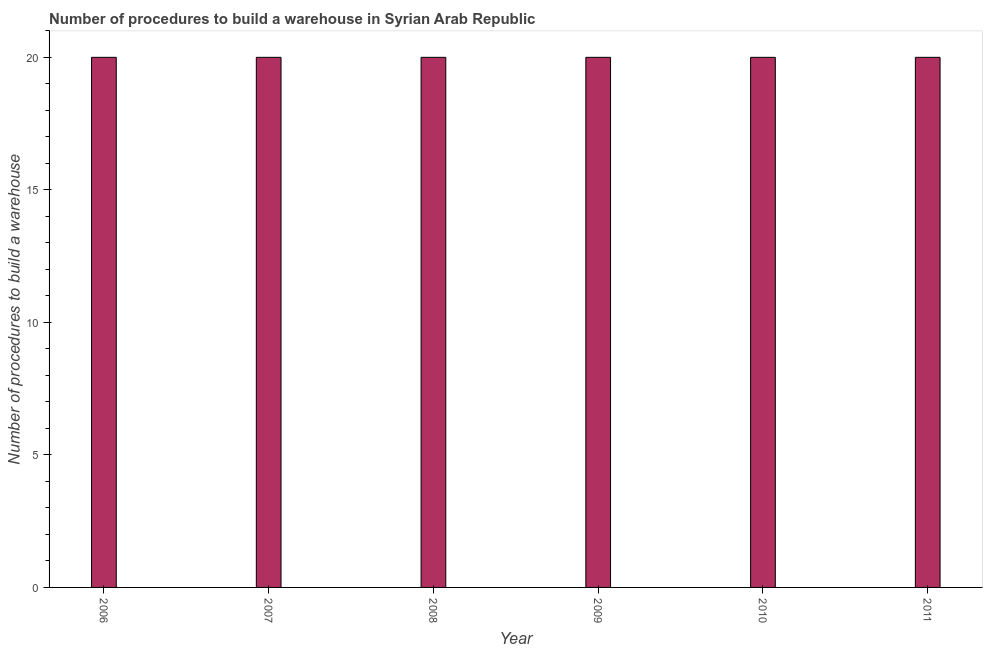Does the graph contain any zero values?
Your answer should be compact. No. What is the title of the graph?
Ensure brevity in your answer.  Number of procedures to build a warehouse in Syrian Arab Republic. What is the label or title of the Y-axis?
Provide a short and direct response. Number of procedures to build a warehouse. Across all years, what is the maximum number of procedures to build a warehouse?
Keep it short and to the point. 20. What is the sum of the number of procedures to build a warehouse?
Provide a short and direct response. 120. What is the difference between the number of procedures to build a warehouse in 2006 and 2009?
Give a very brief answer. 0. What is the median number of procedures to build a warehouse?
Your answer should be compact. 20. What is the ratio of the number of procedures to build a warehouse in 2007 to that in 2011?
Ensure brevity in your answer.  1. Is the number of procedures to build a warehouse in 2006 less than that in 2007?
Make the answer very short. No. Is the difference between the number of procedures to build a warehouse in 2008 and 2009 greater than the difference between any two years?
Provide a succinct answer. Yes. Is the sum of the number of procedures to build a warehouse in 2006 and 2011 greater than the maximum number of procedures to build a warehouse across all years?
Your answer should be compact. Yes. What is the difference between the highest and the lowest number of procedures to build a warehouse?
Provide a short and direct response. 0. How many bars are there?
Your response must be concise. 6. Are all the bars in the graph horizontal?
Provide a succinct answer. No. What is the difference between two consecutive major ticks on the Y-axis?
Your answer should be very brief. 5. Are the values on the major ticks of Y-axis written in scientific E-notation?
Give a very brief answer. No. What is the Number of procedures to build a warehouse in 2006?
Give a very brief answer. 20. What is the Number of procedures to build a warehouse of 2008?
Offer a very short reply. 20. What is the difference between the Number of procedures to build a warehouse in 2006 and 2007?
Ensure brevity in your answer.  0. What is the difference between the Number of procedures to build a warehouse in 2006 and 2011?
Provide a short and direct response. 0. What is the difference between the Number of procedures to build a warehouse in 2007 and 2008?
Your answer should be very brief. 0. What is the difference between the Number of procedures to build a warehouse in 2007 and 2009?
Make the answer very short. 0. What is the difference between the Number of procedures to build a warehouse in 2007 and 2010?
Your answer should be very brief. 0. What is the difference between the Number of procedures to build a warehouse in 2007 and 2011?
Offer a very short reply. 0. What is the difference between the Number of procedures to build a warehouse in 2008 and 2010?
Ensure brevity in your answer.  0. What is the difference between the Number of procedures to build a warehouse in 2009 and 2011?
Provide a succinct answer. 0. What is the difference between the Number of procedures to build a warehouse in 2010 and 2011?
Your answer should be very brief. 0. What is the ratio of the Number of procedures to build a warehouse in 2006 to that in 2007?
Your answer should be very brief. 1. What is the ratio of the Number of procedures to build a warehouse in 2006 to that in 2008?
Offer a terse response. 1. What is the ratio of the Number of procedures to build a warehouse in 2006 to that in 2009?
Give a very brief answer. 1. What is the ratio of the Number of procedures to build a warehouse in 2006 to that in 2011?
Provide a short and direct response. 1. What is the ratio of the Number of procedures to build a warehouse in 2007 to that in 2008?
Give a very brief answer. 1. What is the ratio of the Number of procedures to build a warehouse in 2007 to that in 2009?
Make the answer very short. 1. What is the ratio of the Number of procedures to build a warehouse in 2008 to that in 2011?
Offer a terse response. 1. 